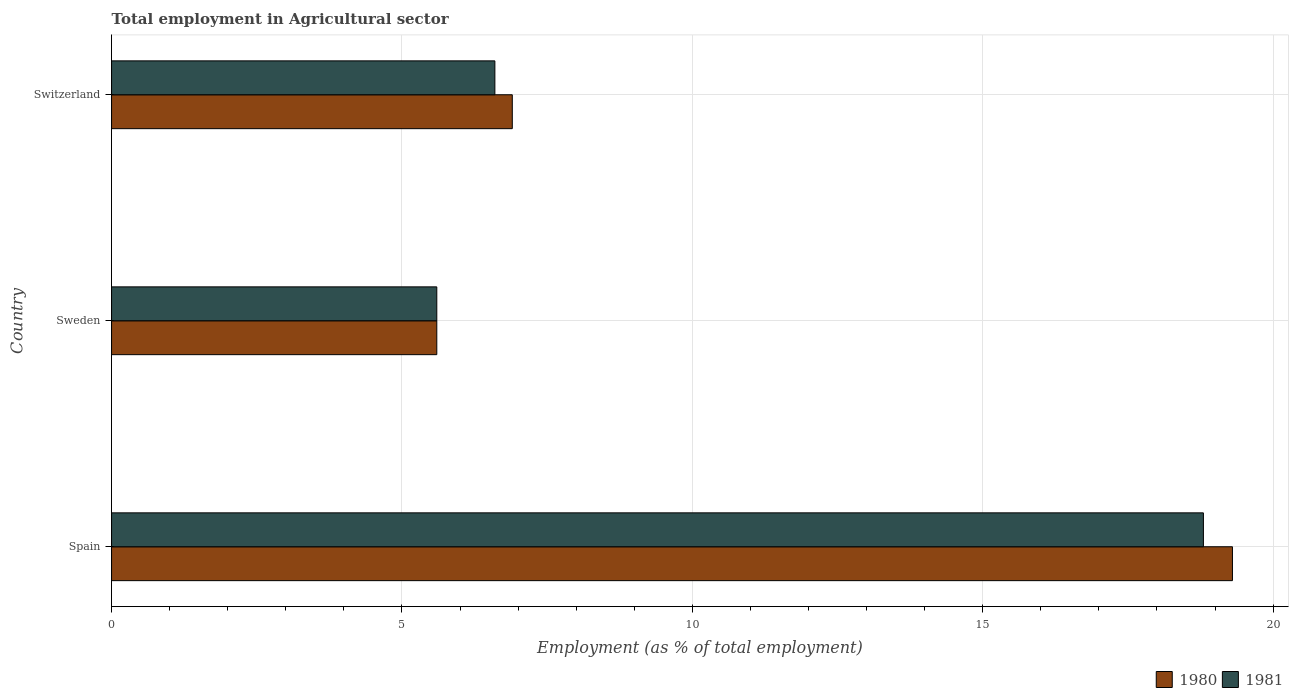How many groups of bars are there?
Your answer should be compact. 3. Are the number of bars per tick equal to the number of legend labels?
Provide a short and direct response. Yes. Are the number of bars on each tick of the Y-axis equal?
Ensure brevity in your answer.  Yes. How many bars are there on the 1st tick from the top?
Your response must be concise. 2. How many bars are there on the 3rd tick from the bottom?
Make the answer very short. 2. What is the label of the 2nd group of bars from the top?
Provide a short and direct response. Sweden. What is the employment in agricultural sector in 1981 in Switzerland?
Your answer should be very brief. 6.6. Across all countries, what is the maximum employment in agricultural sector in 1980?
Your response must be concise. 19.3. Across all countries, what is the minimum employment in agricultural sector in 1980?
Provide a succinct answer. 5.6. In which country was the employment in agricultural sector in 1981 maximum?
Keep it short and to the point. Spain. In which country was the employment in agricultural sector in 1980 minimum?
Your answer should be very brief. Sweden. What is the total employment in agricultural sector in 1980 in the graph?
Keep it short and to the point. 31.8. What is the difference between the employment in agricultural sector in 1980 in Sweden and that in Switzerland?
Ensure brevity in your answer.  -1.3. What is the difference between the employment in agricultural sector in 1980 in Switzerland and the employment in agricultural sector in 1981 in Sweden?
Your answer should be very brief. 1.3. What is the average employment in agricultural sector in 1981 per country?
Give a very brief answer. 10.33. What is the difference between the employment in agricultural sector in 1981 and employment in agricultural sector in 1980 in Sweden?
Offer a very short reply. 0. What is the ratio of the employment in agricultural sector in 1981 in Sweden to that in Switzerland?
Provide a short and direct response. 0.85. Is the employment in agricultural sector in 1980 in Spain less than that in Switzerland?
Make the answer very short. No. What is the difference between the highest and the second highest employment in agricultural sector in 1980?
Your answer should be very brief. 12.4. What is the difference between the highest and the lowest employment in agricultural sector in 1981?
Keep it short and to the point. 13.2. What does the 2nd bar from the bottom in Spain represents?
Keep it short and to the point. 1981. How many bars are there?
Provide a short and direct response. 6. Are all the bars in the graph horizontal?
Give a very brief answer. Yes. Are the values on the major ticks of X-axis written in scientific E-notation?
Your response must be concise. No. How are the legend labels stacked?
Keep it short and to the point. Horizontal. What is the title of the graph?
Provide a short and direct response. Total employment in Agricultural sector. What is the label or title of the X-axis?
Provide a succinct answer. Employment (as % of total employment). What is the label or title of the Y-axis?
Ensure brevity in your answer.  Country. What is the Employment (as % of total employment) in 1980 in Spain?
Make the answer very short. 19.3. What is the Employment (as % of total employment) of 1981 in Spain?
Ensure brevity in your answer.  18.8. What is the Employment (as % of total employment) in 1980 in Sweden?
Your response must be concise. 5.6. What is the Employment (as % of total employment) in 1981 in Sweden?
Your response must be concise. 5.6. What is the Employment (as % of total employment) of 1980 in Switzerland?
Offer a terse response. 6.9. What is the Employment (as % of total employment) in 1981 in Switzerland?
Keep it short and to the point. 6.6. Across all countries, what is the maximum Employment (as % of total employment) of 1980?
Offer a very short reply. 19.3. Across all countries, what is the maximum Employment (as % of total employment) in 1981?
Provide a succinct answer. 18.8. Across all countries, what is the minimum Employment (as % of total employment) of 1980?
Provide a succinct answer. 5.6. Across all countries, what is the minimum Employment (as % of total employment) of 1981?
Ensure brevity in your answer.  5.6. What is the total Employment (as % of total employment) in 1980 in the graph?
Offer a terse response. 31.8. What is the difference between the Employment (as % of total employment) of 1980 in Spain and that in Sweden?
Keep it short and to the point. 13.7. What is the difference between the Employment (as % of total employment) of 1980 in Spain and that in Switzerland?
Your answer should be very brief. 12.4. What is the difference between the Employment (as % of total employment) of 1980 in Sweden and that in Switzerland?
Make the answer very short. -1.3. What is the difference between the Employment (as % of total employment) of 1981 in Sweden and that in Switzerland?
Provide a succinct answer. -1. What is the average Employment (as % of total employment) in 1981 per country?
Your answer should be very brief. 10.33. What is the ratio of the Employment (as % of total employment) in 1980 in Spain to that in Sweden?
Keep it short and to the point. 3.45. What is the ratio of the Employment (as % of total employment) of 1981 in Spain to that in Sweden?
Your response must be concise. 3.36. What is the ratio of the Employment (as % of total employment) in 1980 in Spain to that in Switzerland?
Keep it short and to the point. 2.8. What is the ratio of the Employment (as % of total employment) in 1981 in Spain to that in Switzerland?
Give a very brief answer. 2.85. What is the ratio of the Employment (as % of total employment) in 1980 in Sweden to that in Switzerland?
Your answer should be very brief. 0.81. What is the ratio of the Employment (as % of total employment) in 1981 in Sweden to that in Switzerland?
Your answer should be very brief. 0.85. What is the difference between the highest and the second highest Employment (as % of total employment) in 1981?
Your answer should be very brief. 12.2. What is the difference between the highest and the lowest Employment (as % of total employment) in 1981?
Offer a very short reply. 13.2. 